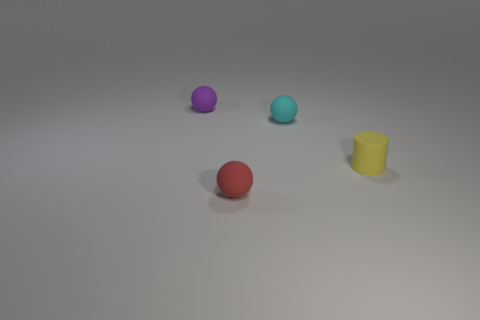Are there more tiny purple matte objects behind the cyan ball than small rubber balls that are behind the tiny purple rubber sphere?
Your response must be concise. Yes. What shape is the small cyan object that is the same material as the purple object?
Provide a short and direct response. Sphere. How many other objects are the same shape as the small red object?
Make the answer very short. 2. What is the shape of the matte object that is on the left side of the red object?
Make the answer very short. Sphere. What material is the sphere that is in front of the tiny rubber ball that is right of the small red thing?
Your response must be concise. Rubber. There is a purple thing; does it have the same size as the yellow thing that is on the right side of the cyan rubber object?
Offer a very short reply. Yes. What is the material of the small object that is in front of the matte cylinder?
Provide a succinct answer. Rubber. Is the size of the purple sphere the same as the red ball?
Offer a terse response. Yes. How big is the matte sphere behind the small rubber ball that is on the right side of the red sphere?
Provide a succinct answer. Small. There is a ball that is both behind the tiny red matte sphere and to the left of the small cyan object; what is its color?
Make the answer very short. Purple. 